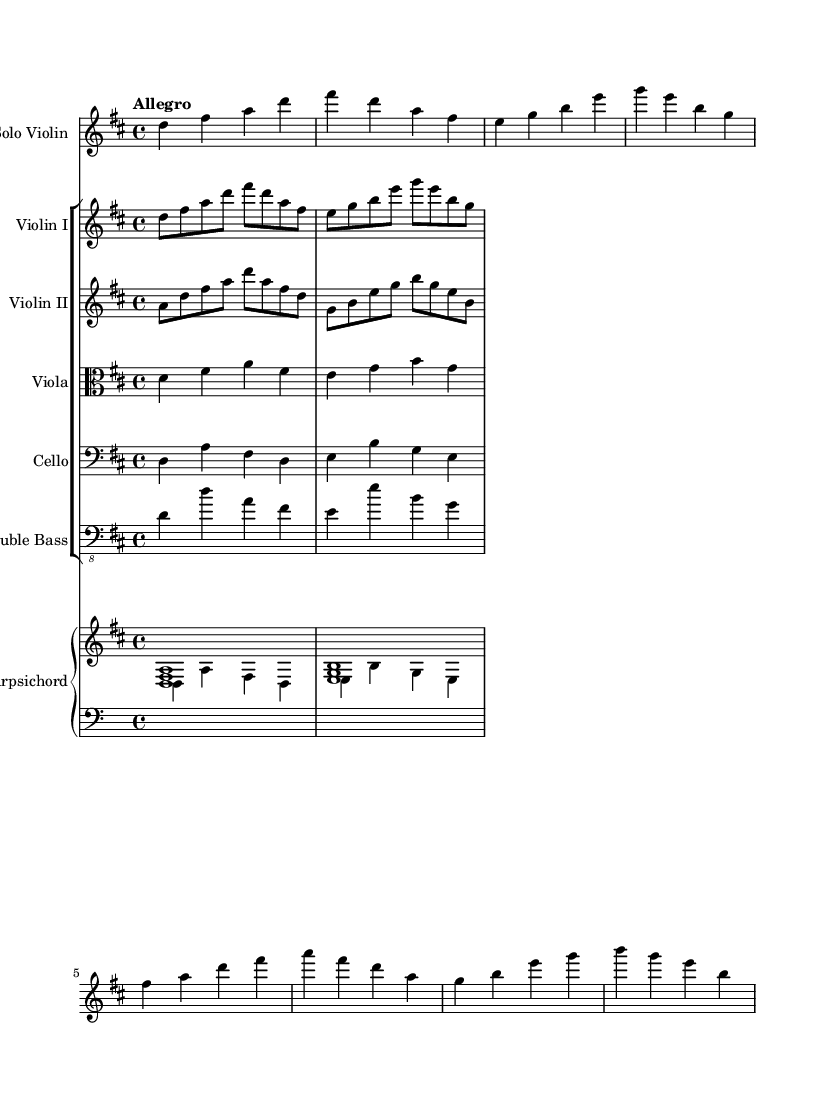What is the key signature of this music? The key signature indicates two sharps, which is typical for D major. This can be identified in the global context of the music where it specifies 'd \major'.
Answer: D major What is the time signature of this music? The time signature shows four beats in a measure, represented as '4/4'. This notation is clearly visible at the beginning of the piece under the global section.
Answer: 4/4 What tempo marking is indicated in this music? The tempo marking 'Allegro' suggests a fast and lively pace. It is written at the beginning of the score in the global section.
Answer: Allegro How many violin parts are present in the score? Analyzing the score, we can see two violin parts labeled as "Violin I" and "Violin II." Both parts can be found in the new StaffGroup section.
Answer: Two What is the melodic pattern of the solo violin in the first measure? The first measure shows the notes D, F sharp, A, and D, which creates a specific melodic shape. This is derived by looking at the note sequence in the violinSolo part within the relative context.
Answer: D F# A D In which voice does the cello primarily play? The cello part is indicated with a bass clef and generally plays a harmonic role rather than a melodic one. The notes indicate foundation support for the harmonic movement implied by the piece.
Answer: Bass What type of ensemble primarily performs this piece? The piece is characterized as a Baroque concerto for string instruments, which is typical of the Classical tradition featuring soloists and a supporting string ensemble. This can be inferred from the instrument list present in the score.
Answer: String ensemble 